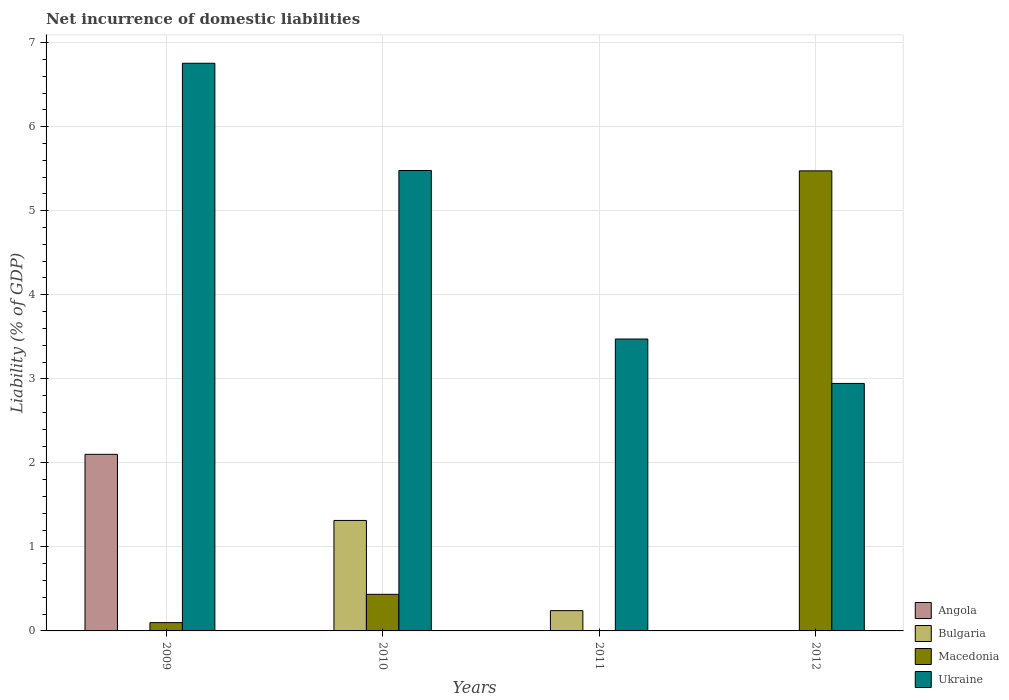How many different coloured bars are there?
Offer a terse response. 4. How many groups of bars are there?
Offer a terse response. 4. Are the number of bars on each tick of the X-axis equal?
Provide a succinct answer. No. How many bars are there on the 4th tick from the left?
Your answer should be compact. 2. What is the net incurrence of domestic liabilities in Bulgaria in 2009?
Give a very brief answer. 0. Across all years, what is the maximum net incurrence of domestic liabilities in Ukraine?
Ensure brevity in your answer.  6.76. Across all years, what is the minimum net incurrence of domestic liabilities in Bulgaria?
Your response must be concise. 0. What is the total net incurrence of domestic liabilities in Ukraine in the graph?
Your response must be concise. 18.65. What is the difference between the net incurrence of domestic liabilities in Bulgaria in 2010 and that in 2011?
Your answer should be compact. 1.07. What is the difference between the net incurrence of domestic liabilities in Macedonia in 2011 and the net incurrence of domestic liabilities in Angola in 2010?
Keep it short and to the point. 0. What is the average net incurrence of domestic liabilities in Ukraine per year?
Your response must be concise. 4.66. In the year 2012, what is the difference between the net incurrence of domestic liabilities in Macedonia and net incurrence of domestic liabilities in Ukraine?
Your answer should be compact. 2.53. In how many years, is the net incurrence of domestic liabilities in Angola greater than 6 %?
Make the answer very short. 0. What is the ratio of the net incurrence of domestic liabilities in Ukraine in 2009 to that in 2010?
Give a very brief answer. 1.23. Is the net incurrence of domestic liabilities in Macedonia in 2010 less than that in 2012?
Provide a short and direct response. Yes. What is the difference between the highest and the second highest net incurrence of domestic liabilities in Macedonia?
Ensure brevity in your answer.  5.04. What is the difference between the highest and the lowest net incurrence of domestic liabilities in Bulgaria?
Make the answer very short. 1.31. Is it the case that in every year, the sum of the net incurrence of domestic liabilities in Angola and net incurrence of domestic liabilities in Bulgaria is greater than the sum of net incurrence of domestic liabilities in Ukraine and net incurrence of domestic liabilities in Macedonia?
Offer a terse response. No. How many bars are there?
Keep it short and to the point. 10. Are all the bars in the graph horizontal?
Give a very brief answer. No. What is the difference between two consecutive major ticks on the Y-axis?
Ensure brevity in your answer.  1. How many legend labels are there?
Offer a very short reply. 4. What is the title of the graph?
Ensure brevity in your answer.  Net incurrence of domestic liabilities. Does "Mauritania" appear as one of the legend labels in the graph?
Ensure brevity in your answer.  No. What is the label or title of the Y-axis?
Provide a short and direct response. Liability (% of GDP). What is the Liability (% of GDP) in Angola in 2009?
Provide a succinct answer. 2.1. What is the Liability (% of GDP) of Bulgaria in 2009?
Provide a short and direct response. 0. What is the Liability (% of GDP) in Macedonia in 2009?
Offer a terse response. 0.1. What is the Liability (% of GDP) in Ukraine in 2009?
Offer a terse response. 6.76. What is the Liability (% of GDP) of Angola in 2010?
Offer a very short reply. 0. What is the Liability (% of GDP) of Bulgaria in 2010?
Offer a terse response. 1.31. What is the Liability (% of GDP) in Macedonia in 2010?
Keep it short and to the point. 0.44. What is the Liability (% of GDP) in Ukraine in 2010?
Ensure brevity in your answer.  5.48. What is the Liability (% of GDP) in Bulgaria in 2011?
Your response must be concise. 0.24. What is the Liability (% of GDP) in Macedonia in 2011?
Offer a terse response. 0. What is the Liability (% of GDP) in Ukraine in 2011?
Your answer should be compact. 3.47. What is the Liability (% of GDP) in Angola in 2012?
Your answer should be very brief. 0. What is the Liability (% of GDP) in Macedonia in 2012?
Make the answer very short. 5.48. What is the Liability (% of GDP) of Ukraine in 2012?
Your answer should be very brief. 2.95. Across all years, what is the maximum Liability (% of GDP) of Angola?
Your answer should be compact. 2.1. Across all years, what is the maximum Liability (% of GDP) of Bulgaria?
Your answer should be compact. 1.31. Across all years, what is the maximum Liability (% of GDP) in Macedonia?
Your answer should be very brief. 5.48. Across all years, what is the maximum Liability (% of GDP) in Ukraine?
Your response must be concise. 6.76. Across all years, what is the minimum Liability (% of GDP) of Angola?
Your answer should be compact. 0. Across all years, what is the minimum Liability (% of GDP) in Bulgaria?
Offer a terse response. 0. Across all years, what is the minimum Liability (% of GDP) in Ukraine?
Your response must be concise. 2.95. What is the total Liability (% of GDP) of Angola in the graph?
Ensure brevity in your answer.  2.1. What is the total Liability (% of GDP) in Bulgaria in the graph?
Ensure brevity in your answer.  1.56. What is the total Liability (% of GDP) in Macedonia in the graph?
Keep it short and to the point. 6.01. What is the total Liability (% of GDP) of Ukraine in the graph?
Provide a short and direct response. 18.65. What is the difference between the Liability (% of GDP) in Macedonia in 2009 and that in 2010?
Provide a succinct answer. -0.34. What is the difference between the Liability (% of GDP) of Ukraine in 2009 and that in 2010?
Offer a terse response. 1.28. What is the difference between the Liability (% of GDP) in Ukraine in 2009 and that in 2011?
Your answer should be compact. 3.28. What is the difference between the Liability (% of GDP) in Macedonia in 2009 and that in 2012?
Your response must be concise. -5.38. What is the difference between the Liability (% of GDP) of Ukraine in 2009 and that in 2012?
Your answer should be compact. 3.81. What is the difference between the Liability (% of GDP) in Bulgaria in 2010 and that in 2011?
Keep it short and to the point. 1.07. What is the difference between the Liability (% of GDP) in Ukraine in 2010 and that in 2011?
Make the answer very short. 2.01. What is the difference between the Liability (% of GDP) in Macedonia in 2010 and that in 2012?
Give a very brief answer. -5.04. What is the difference between the Liability (% of GDP) of Ukraine in 2010 and that in 2012?
Your response must be concise. 2.53. What is the difference between the Liability (% of GDP) in Ukraine in 2011 and that in 2012?
Give a very brief answer. 0.53. What is the difference between the Liability (% of GDP) in Angola in 2009 and the Liability (% of GDP) in Bulgaria in 2010?
Your answer should be very brief. 0.79. What is the difference between the Liability (% of GDP) of Angola in 2009 and the Liability (% of GDP) of Macedonia in 2010?
Give a very brief answer. 1.67. What is the difference between the Liability (% of GDP) in Angola in 2009 and the Liability (% of GDP) in Ukraine in 2010?
Offer a very short reply. -3.38. What is the difference between the Liability (% of GDP) of Macedonia in 2009 and the Liability (% of GDP) of Ukraine in 2010?
Provide a succinct answer. -5.38. What is the difference between the Liability (% of GDP) in Angola in 2009 and the Liability (% of GDP) in Bulgaria in 2011?
Provide a short and direct response. 1.86. What is the difference between the Liability (% of GDP) in Angola in 2009 and the Liability (% of GDP) in Ukraine in 2011?
Make the answer very short. -1.37. What is the difference between the Liability (% of GDP) of Macedonia in 2009 and the Liability (% of GDP) of Ukraine in 2011?
Keep it short and to the point. -3.37. What is the difference between the Liability (% of GDP) of Angola in 2009 and the Liability (% of GDP) of Macedonia in 2012?
Provide a short and direct response. -3.37. What is the difference between the Liability (% of GDP) in Angola in 2009 and the Liability (% of GDP) in Ukraine in 2012?
Your response must be concise. -0.84. What is the difference between the Liability (% of GDP) in Macedonia in 2009 and the Liability (% of GDP) in Ukraine in 2012?
Keep it short and to the point. -2.85. What is the difference between the Liability (% of GDP) of Bulgaria in 2010 and the Liability (% of GDP) of Ukraine in 2011?
Offer a very short reply. -2.16. What is the difference between the Liability (% of GDP) of Macedonia in 2010 and the Liability (% of GDP) of Ukraine in 2011?
Ensure brevity in your answer.  -3.04. What is the difference between the Liability (% of GDP) of Bulgaria in 2010 and the Liability (% of GDP) of Macedonia in 2012?
Provide a short and direct response. -4.16. What is the difference between the Liability (% of GDP) of Bulgaria in 2010 and the Liability (% of GDP) of Ukraine in 2012?
Your response must be concise. -1.63. What is the difference between the Liability (% of GDP) of Macedonia in 2010 and the Liability (% of GDP) of Ukraine in 2012?
Keep it short and to the point. -2.51. What is the difference between the Liability (% of GDP) of Bulgaria in 2011 and the Liability (% of GDP) of Macedonia in 2012?
Offer a very short reply. -5.23. What is the difference between the Liability (% of GDP) in Bulgaria in 2011 and the Liability (% of GDP) in Ukraine in 2012?
Keep it short and to the point. -2.7. What is the average Liability (% of GDP) in Angola per year?
Your answer should be compact. 0.53. What is the average Liability (% of GDP) of Bulgaria per year?
Make the answer very short. 0.39. What is the average Liability (% of GDP) in Macedonia per year?
Your answer should be very brief. 1.5. What is the average Liability (% of GDP) in Ukraine per year?
Offer a very short reply. 4.66. In the year 2009, what is the difference between the Liability (% of GDP) of Angola and Liability (% of GDP) of Macedonia?
Keep it short and to the point. 2. In the year 2009, what is the difference between the Liability (% of GDP) in Angola and Liability (% of GDP) in Ukraine?
Your answer should be very brief. -4.65. In the year 2009, what is the difference between the Liability (% of GDP) of Macedonia and Liability (% of GDP) of Ukraine?
Your answer should be very brief. -6.66. In the year 2010, what is the difference between the Liability (% of GDP) in Bulgaria and Liability (% of GDP) in Macedonia?
Provide a short and direct response. 0.88. In the year 2010, what is the difference between the Liability (% of GDP) in Bulgaria and Liability (% of GDP) in Ukraine?
Provide a succinct answer. -4.16. In the year 2010, what is the difference between the Liability (% of GDP) in Macedonia and Liability (% of GDP) in Ukraine?
Offer a terse response. -5.04. In the year 2011, what is the difference between the Liability (% of GDP) in Bulgaria and Liability (% of GDP) in Ukraine?
Your answer should be compact. -3.23. In the year 2012, what is the difference between the Liability (% of GDP) in Macedonia and Liability (% of GDP) in Ukraine?
Your response must be concise. 2.53. What is the ratio of the Liability (% of GDP) in Macedonia in 2009 to that in 2010?
Ensure brevity in your answer.  0.23. What is the ratio of the Liability (% of GDP) of Ukraine in 2009 to that in 2010?
Your answer should be compact. 1.23. What is the ratio of the Liability (% of GDP) of Ukraine in 2009 to that in 2011?
Provide a succinct answer. 1.94. What is the ratio of the Liability (% of GDP) in Macedonia in 2009 to that in 2012?
Give a very brief answer. 0.02. What is the ratio of the Liability (% of GDP) in Ukraine in 2009 to that in 2012?
Make the answer very short. 2.29. What is the ratio of the Liability (% of GDP) of Bulgaria in 2010 to that in 2011?
Your answer should be compact. 5.45. What is the ratio of the Liability (% of GDP) in Ukraine in 2010 to that in 2011?
Your response must be concise. 1.58. What is the ratio of the Liability (% of GDP) of Macedonia in 2010 to that in 2012?
Ensure brevity in your answer.  0.08. What is the ratio of the Liability (% of GDP) in Ukraine in 2010 to that in 2012?
Make the answer very short. 1.86. What is the ratio of the Liability (% of GDP) of Ukraine in 2011 to that in 2012?
Your answer should be very brief. 1.18. What is the difference between the highest and the second highest Liability (% of GDP) in Macedonia?
Make the answer very short. 5.04. What is the difference between the highest and the second highest Liability (% of GDP) of Ukraine?
Give a very brief answer. 1.28. What is the difference between the highest and the lowest Liability (% of GDP) of Angola?
Keep it short and to the point. 2.1. What is the difference between the highest and the lowest Liability (% of GDP) in Bulgaria?
Give a very brief answer. 1.31. What is the difference between the highest and the lowest Liability (% of GDP) of Macedonia?
Provide a succinct answer. 5.47. What is the difference between the highest and the lowest Liability (% of GDP) in Ukraine?
Provide a succinct answer. 3.81. 